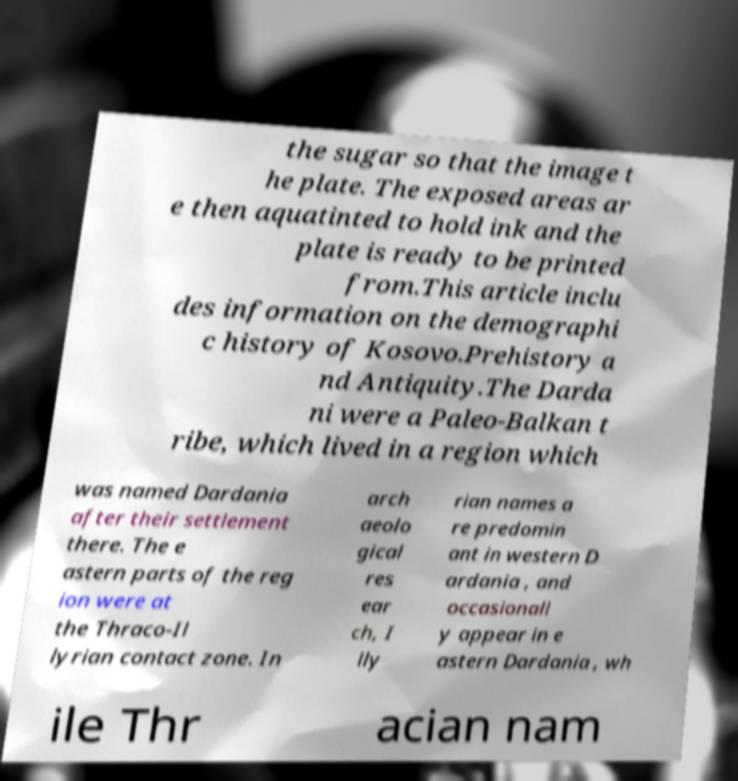Can you read and provide the text displayed in the image?This photo seems to have some interesting text. Can you extract and type it out for me? the sugar so that the image t he plate. The exposed areas ar e then aquatinted to hold ink and the plate is ready to be printed from.This article inclu des information on the demographi c history of Kosovo.Prehistory a nd Antiquity.The Darda ni were a Paleo-Balkan t ribe, which lived in a region which was named Dardania after their settlement there. The e astern parts of the reg ion were at the Thraco-Il lyrian contact zone. In arch aeolo gical res ear ch, I lly rian names a re predomin ant in western D ardania , and occasionall y appear in e astern Dardania , wh ile Thr acian nam 